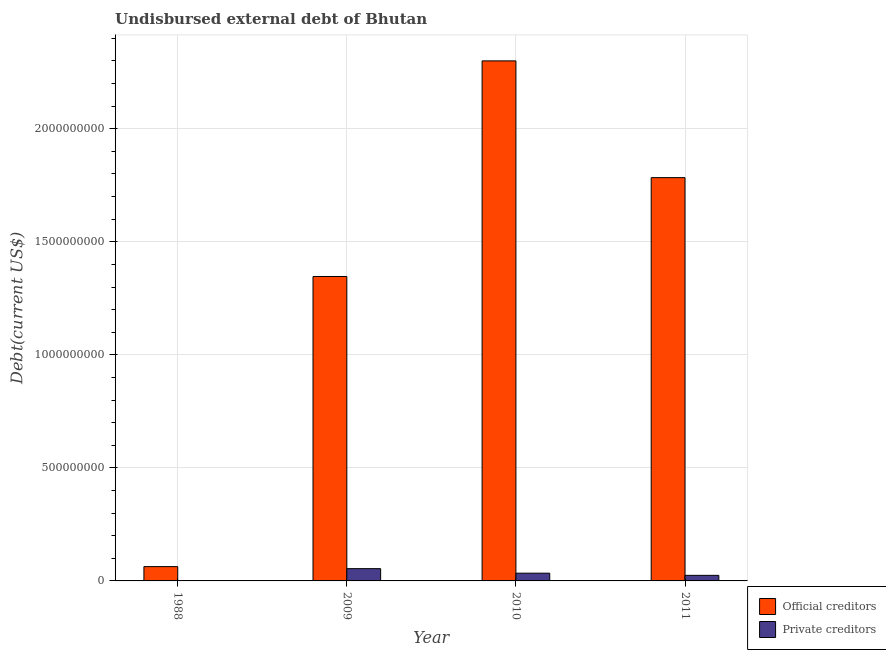How many groups of bars are there?
Make the answer very short. 4. Are the number of bars per tick equal to the number of legend labels?
Give a very brief answer. Yes. Are the number of bars on each tick of the X-axis equal?
Provide a succinct answer. Yes. How many bars are there on the 1st tick from the right?
Offer a terse response. 2. In how many cases, is the number of bars for a given year not equal to the number of legend labels?
Your answer should be very brief. 0. What is the undisbursed external debt of official creditors in 2011?
Your answer should be very brief. 1.78e+09. Across all years, what is the maximum undisbursed external debt of private creditors?
Offer a terse response. 5.43e+07. Across all years, what is the minimum undisbursed external debt of official creditors?
Provide a succinct answer. 6.33e+07. In which year was the undisbursed external debt of private creditors maximum?
Offer a terse response. 2009. In which year was the undisbursed external debt of private creditors minimum?
Your response must be concise. 1988. What is the total undisbursed external debt of official creditors in the graph?
Offer a terse response. 5.49e+09. What is the difference between the undisbursed external debt of official creditors in 1988 and that in 2009?
Your answer should be very brief. -1.28e+09. What is the difference between the undisbursed external debt of private creditors in 1988 and the undisbursed external debt of official creditors in 2011?
Your response must be concise. -2.41e+07. What is the average undisbursed external debt of private creditors per year?
Ensure brevity in your answer.  2.84e+07. In how many years, is the undisbursed external debt of official creditors greater than 2300000000 US$?
Ensure brevity in your answer.  1. What is the ratio of the undisbursed external debt of official creditors in 2009 to that in 2010?
Provide a short and direct response. 0.59. Is the undisbursed external debt of private creditors in 2009 less than that in 2011?
Keep it short and to the point. No. What is the difference between the highest and the second highest undisbursed external debt of official creditors?
Provide a short and direct response. 5.16e+08. What is the difference between the highest and the lowest undisbursed external debt of private creditors?
Your response must be concise. 5.38e+07. Is the sum of the undisbursed external debt of private creditors in 1988 and 2011 greater than the maximum undisbursed external debt of official creditors across all years?
Your answer should be very brief. No. What does the 2nd bar from the left in 1988 represents?
Ensure brevity in your answer.  Private creditors. What does the 1st bar from the right in 2010 represents?
Offer a terse response. Private creditors. What is the difference between two consecutive major ticks on the Y-axis?
Keep it short and to the point. 5.00e+08. Are the values on the major ticks of Y-axis written in scientific E-notation?
Offer a very short reply. No. Does the graph contain any zero values?
Make the answer very short. No. Does the graph contain grids?
Your answer should be compact. Yes. Where does the legend appear in the graph?
Give a very brief answer. Bottom right. What is the title of the graph?
Keep it short and to the point. Undisbursed external debt of Bhutan. What is the label or title of the Y-axis?
Make the answer very short. Debt(current US$). What is the Debt(current US$) in Official creditors in 1988?
Your answer should be compact. 6.33e+07. What is the Debt(current US$) of Private creditors in 1988?
Keep it short and to the point. 4.93e+05. What is the Debt(current US$) in Official creditors in 2009?
Your answer should be very brief. 1.35e+09. What is the Debt(current US$) in Private creditors in 2009?
Make the answer very short. 5.43e+07. What is the Debt(current US$) in Official creditors in 2010?
Offer a very short reply. 2.30e+09. What is the Debt(current US$) in Private creditors in 2010?
Keep it short and to the point. 3.42e+07. What is the Debt(current US$) in Official creditors in 2011?
Your response must be concise. 1.78e+09. What is the Debt(current US$) of Private creditors in 2011?
Make the answer very short. 2.46e+07. Across all years, what is the maximum Debt(current US$) in Official creditors?
Offer a very short reply. 2.30e+09. Across all years, what is the maximum Debt(current US$) of Private creditors?
Offer a very short reply. 5.43e+07. Across all years, what is the minimum Debt(current US$) of Official creditors?
Ensure brevity in your answer.  6.33e+07. Across all years, what is the minimum Debt(current US$) of Private creditors?
Offer a terse response. 4.93e+05. What is the total Debt(current US$) of Official creditors in the graph?
Give a very brief answer. 5.49e+09. What is the total Debt(current US$) of Private creditors in the graph?
Keep it short and to the point. 1.14e+08. What is the difference between the Debt(current US$) of Official creditors in 1988 and that in 2009?
Provide a short and direct response. -1.28e+09. What is the difference between the Debt(current US$) in Private creditors in 1988 and that in 2009?
Ensure brevity in your answer.  -5.38e+07. What is the difference between the Debt(current US$) in Official creditors in 1988 and that in 2010?
Make the answer very short. -2.24e+09. What is the difference between the Debt(current US$) in Private creditors in 1988 and that in 2010?
Make the answer very short. -3.37e+07. What is the difference between the Debt(current US$) in Official creditors in 1988 and that in 2011?
Offer a very short reply. -1.72e+09. What is the difference between the Debt(current US$) of Private creditors in 1988 and that in 2011?
Ensure brevity in your answer.  -2.41e+07. What is the difference between the Debt(current US$) in Official creditors in 2009 and that in 2010?
Your response must be concise. -9.54e+08. What is the difference between the Debt(current US$) in Private creditors in 2009 and that in 2010?
Your answer should be very brief. 2.01e+07. What is the difference between the Debt(current US$) of Official creditors in 2009 and that in 2011?
Offer a terse response. -4.37e+08. What is the difference between the Debt(current US$) in Private creditors in 2009 and that in 2011?
Give a very brief answer. 2.97e+07. What is the difference between the Debt(current US$) in Official creditors in 2010 and that in 2011?
Your answer should be compact. 5.16e+08. What is the difference between the Debt(current US$) of Private creditors in 2010 and that in 2011?
Keep it short and to the point. 9.60e+06. What is the difference between the Debt(current US$) in Official creditors in 1988 and the Debt(current US$) in Private creditors in 2009?
Offer a terse response. 8.98e+06. What is the difference between the Debt(current US$) of Official creditors in 1988 and the Debt(current US$) of Private creditors in 2010?
Offer a terse response. 2.91e+07. What is the difference between the Debt(current US$) in Official creditors in 1988 and the Debt(current US$) in Private creditors in 2011?
Make the answer very short. 3.87e+07. What is the difference between the Debt(current US$) in Official creditors in 2009 and the Debt(current US$) in Private creditors in 2010?
Your answer should be very brief. 1.31e+09. What is the difference between the Debt(current US$) in Official creditors in 2009 and the Debt(current US$) in Private creditors in 2011?
Keep it short and to the point. 1.32e+09. What is the difference between the Debt(current US$) in Official creditors in 2010 and the Debt(current US$) in Private creditors in 2011?
Give a very brief answer. 2.28e+09. What is the average Debt(current US$) in Official creditors per year?
Your response must be concise. 1.37e+09. What is the average Debt(current US$) in Private creditors per year?
Your response must be concise. 2.84e+07. In the year 1988, what is the difference between the Debt(current US$) in Official creditors and Debt(current US$) in Private creditors?
Offer a terse response. 6.28e+07. In the year 2009, what is the difference between the Debt(current US$) of Official creditors and Debt(current US$) of Private creditors?
Your response must be concise. 1.29e+09. In the year 2010, what is the difference between the Debt(current US$) in Official creditors and Debt(current US$) in Private creditors?
Ensure brevity in your answer.  2.27e+09. In the year 2011, what is the difference between the Debt(current US$) of Official creditors and Debt(current US$) of Private creditors?
Your response must be concise. 1.76e+09. What is the ratio of the Debt(current US$) in Official creditors in 1988 to that in 2009?
Your response must be concise. 0.05. What is the ratio of the Debt(current US$) in Private creditors in 1988 to that in 2009?
Your answer should be very brief. 0.01. What is the ratio of the Debt(current US$) of Official creditors in 1988 to that in 2010?
Provide a succinct answer. 0.03. What is the ratio of the Debt(current US$) of Private creditors in 1988 to that in 2010?
Your response must be concise. 0.01. What is the ratio of the Debt(current US$) of Official creditors in 1988 to that in 2011?
Provide a short and direct response. 0.04. What is the ratio of the Debt(current US$) in Private creditors in 1988 to that in 2011?
Make the answer very short. 0.02. What is the ratio of the Debt(current US$) in Official creditors in 2009 to that in 2010?
Your response must be concise. 0.59. What is the ratio of the Debt(current US$) of Private creditors in 2009 to that in 2010?
Make the answer very short. 1.59. What is the ratio of the Debt(current US$) in Official creditors in 2009 to that in 2011?
Provide a succinct answer. 0.75. What is the ratio of the Debt(current US$) in Private creditors in 2009 to that in 2011?
Offer a terse response. 2.21. What is the ratio of the Debt(current US$) in Official creditors in 2010 to that in 2011?
Provide a succinct answer. 1.29. What is the ratio of the Debt(current US$) of Private creditors in 2010 to that in 2011?
Your response must be concise. 1.39. What is the difference between the highest and the second highest Debt(current US$) of Official creditors?
Offer a very short reply. 5.16e+08. What is the difference between the highest and the second highest Debt(current US$) in Private creditors?
Offer a terse response. 2.01e+07. What is the difference between the highest and the lowest Debt(current US$) of Official creditors?
Ensure brevity in your answer.  2.24e+09. What is the difference between the highest and the lowest Debt(current US$) of Private creditors?
Provide a succinct answer. 5.38e+07. 